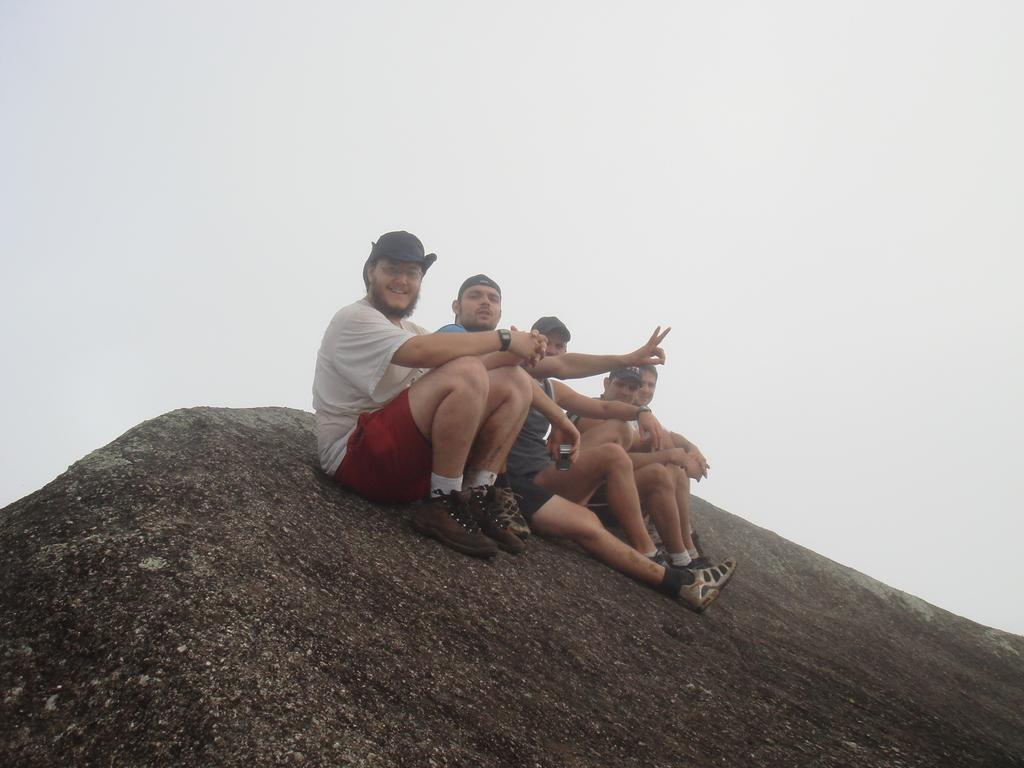What is happening in the image? There is a group of people sitting in the image. Can you describe the clothing of the person at the front? The person at the front is wearing a white shirt and red shorts. What can be seen in the background of the image? The sky is visible in the background of the image, with colors white and blue. How many details can be seen on the person's feet in the image? There is no specific detail about the person's feet mentioned in the facts, so it cannot be determined from the image. Is there a knot tied on the person's shirt in the image? There is no mention of a knot or any specific detail about the person's shirt besides its color, so it cannot be determined from the image. 